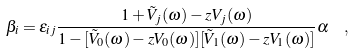<formula> <loc_0><loc_0><loc_500><loc_500>\beta _ { i } = \epsilon _ { i j } \frac { 1 + \tilde { V } _ { j } ( \omega ) - z V _ { j } ( \omega ) } { 1 - [ \tilde { V } _ { 0 } ( \omega ) - z V _ { 0 } ( \omega ) ] [ \tilde { V } _ { 1 } ( \omega ) - z V _ { 1 } ( \omega ) ] } \alpha \ \ ,</formula> 